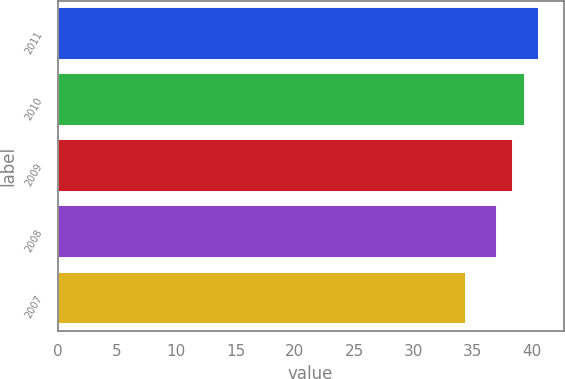<chart> <loc_0><loc_0><loc_500><loc_500><bar_chart><fcel>2011<fcel>2010<fcel>2009<fcel>2008<fcel>2007<nl><fcel>40.63<fcel>39.42<fcel>38.37<fcel>37.03<fcel>34.47<nl></chart> 